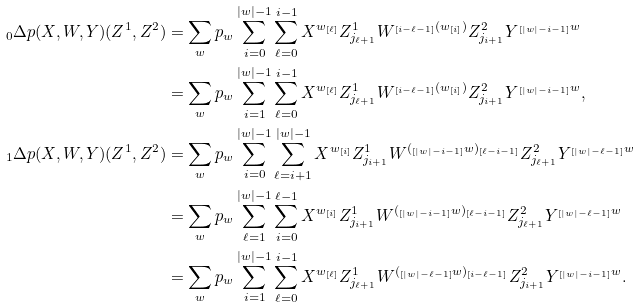<formula> <loc_0><loc_0><loc_500><loc_500>{ _ { 0 } \Delta } p ( X , W , Y ) ( Z ^ { 1 } , Z ^ { 2 } ) & = \sum _ { w } p _ { w } \sum _ { i = 0 } ^ { | w | - 1 } \sum _ { \ell = 0 } ^ { i - 1 } X ^ { w _ { [ \ell ] } } Z ^ { 1 } _ { j _ { \ell + 1 } } W ^ { _ { [ i - \ell - 1 ] } { ( w _ { [ i ] } ) } } Z ^ { 2 } _ { j _ { i + 1 } } Y ^ { _ { [ | w | - i - 1 ] } w } \\ & = \sum _ { w } p _ { w } \sum _ { i = 1 } ^ { | w | - 1 } \sum _ { \ell = 0 } ^ { i - 1 } X ^ { w _ { [ \ell ] } } Z ^ { 1 } _ { j _ { \ell + 1 } } W ^ { _ { [ i - \ell - 1 ] } { ( w _ { [ i ] } ) } } Z ^ { 2 } _ { j _ { i + 1 } } Y ^ { _ { [ | w | - i - 1 ] } w } , \\ { _ { 1 } \Delta } p ( X , W , Y ) ( Z ^ { 1 } , Z ^ { 2 } ) & = \sum _ { w } p _ { w } \sum _ { i = 0 } ^ { | w | - 1 } \sum _ { \ell = i + 1 } ^ { | w | - 1 } X ^ { w _ { [ i ] } } Z ^ { 1 } _ { j _ { i + 1 } } W ^ { ( { _ { [ | w | - i - 1 ] } w } ) _ { [ \ell - i - 1 ] } } Z ^ { 2 } _ { j _ { \ell + 1 } } Y ^ { _ { [ | w | - \ell - 1 ] } w } \\ & = \sum _ { w } p _ { w } \sum _ { \ell = 1 } ^ { | w | - 1 } \sum _ { i = 0 } ^ { \ell - 1 } X ^ { w _ { [ i ] } } Z ^ { 1 } _ { j _ { i + 1 } } W ^ { ( { _ { [ | w | - i - 1 ] } w } ) _ { [ \ell - i - 1 ] } } Z ^ { 2 } _ { j _ { \ell + 1 } } Y ^ { _ { [ | w | - \ell - 1 ] } w } \\ & = \sum _ { w } p _ { w } \sum _ { i = 1 } ^ { | w | - 1 } \sum _ { \ell = 0 } ^ { i - 1 } X ^ { w _ { [ \ell ] } } Z ^ { 1 } _ { j _ { \ell + 1 } } W ^ { ( { _ { [ | w | - \ell - 1 ] } w } ) _ { [ i - \ell - 1 ] } } Z ^ { 2 } _ { j _ { i + 1 } } Y ^ { _ { [ | w | - i - 1 ] } w } .</formula> 